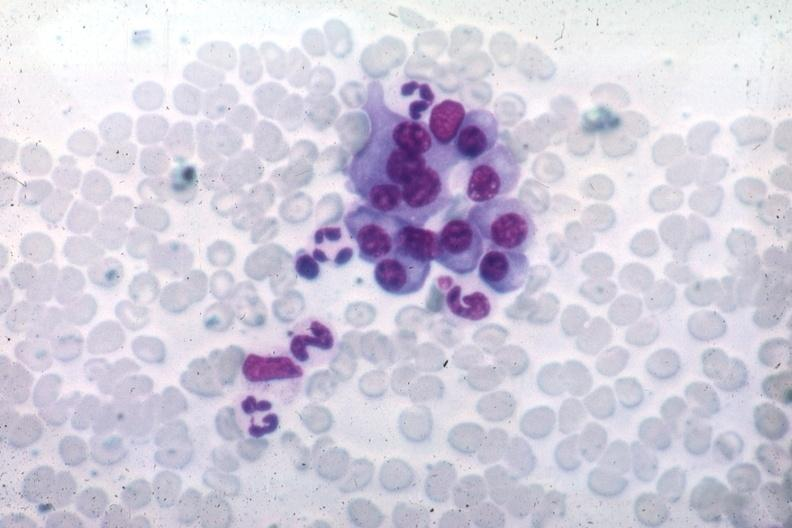s bone marrow present?
Answer the question using a single word or phrase. Yes 